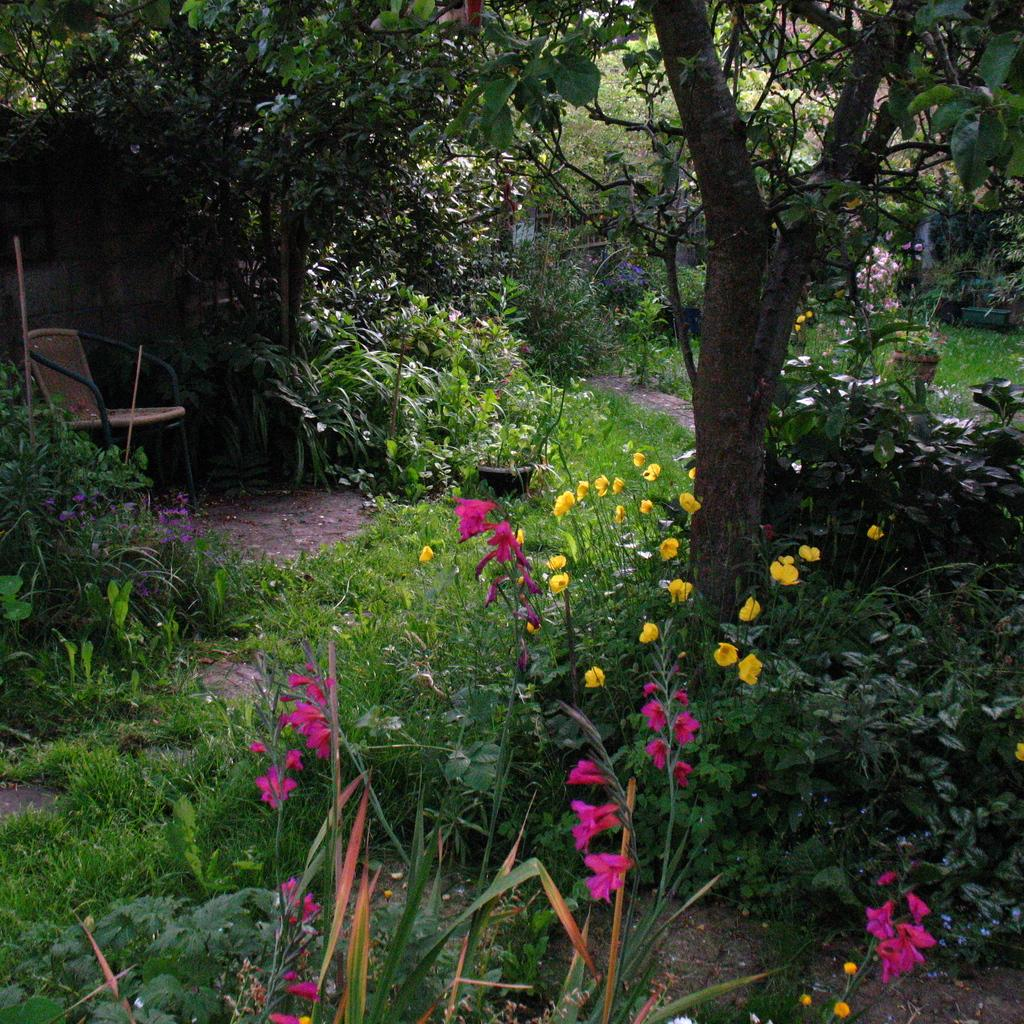What type of vegetation can be seen in the image? There is a tree, plants, and flowers in the image. What type of object is present in the image that might be used for sitting? There is a chair in the image. What type of event is taking place under the tent in the image? There is no tent present in the image, so it is not possible to answer that question. 